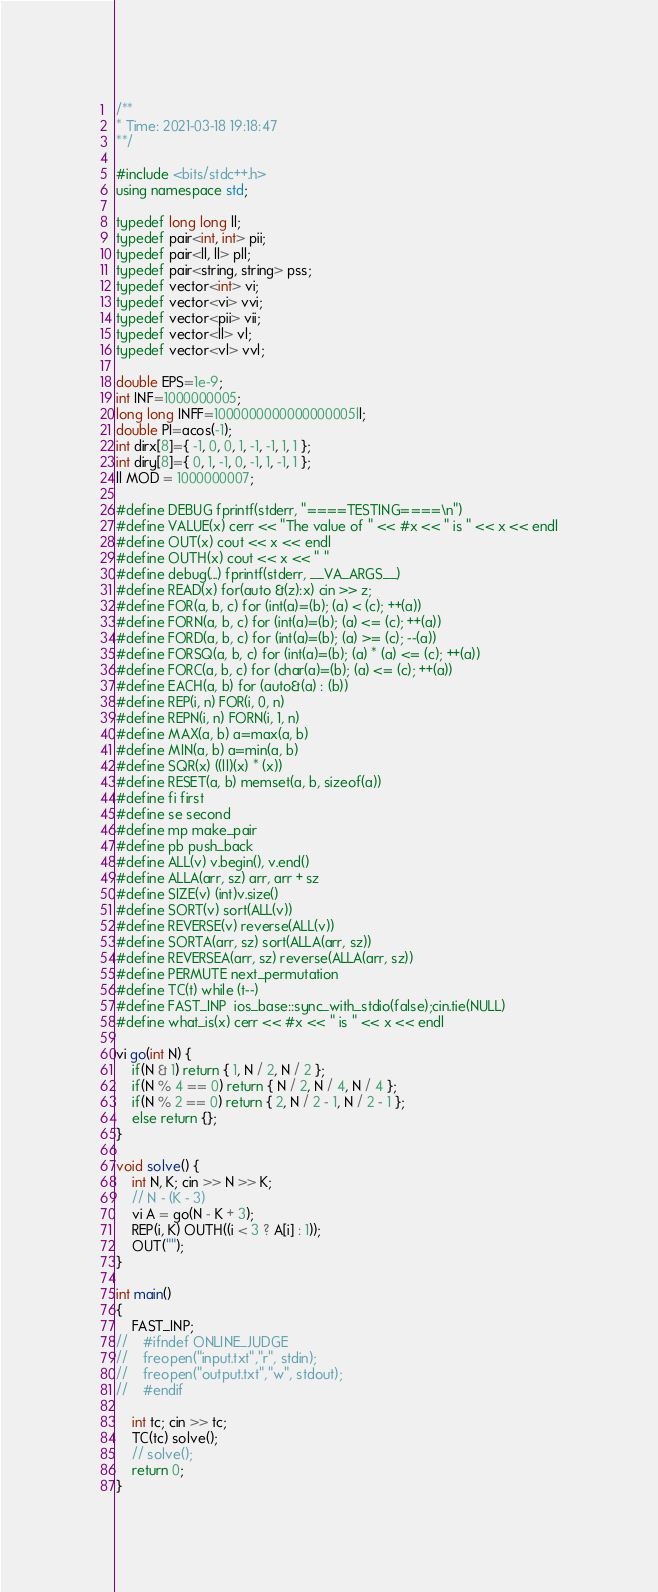Convert code to text. <code><loc_0><loc_0><loc_500><loc_500><_C++_>/** 
* Time: 2021-03-18 19:18:47
**/

#include <bits/stdc++.h>
using namespace std;

typedef long long ll;
typedef pair<int, int> pii;
typedef pair<ll, ll> pll;
typedef pair<string, string> pss;
typedef vector<int> vi;
typedef vector<vi> vvi;
typedef vector<pii> vii;
typedef vector<ll> vl;
typedef vector<vl> vvl;

double EPS=1e-9;
int INF=1000000005;
long long INFF=1000000000000000005ll;
double PI=acos(-1);
int dirx[8]={ -1, 0, 0, 1, -1, -1, 1, 1 };
int diry[8]={ 0, 1, -1, 0, -1, 1, -1, 1 };
ll MOD = 1000000007;

#define DEBUG fprintf(stderr, "====TESTING====\n")
#define VALUE(x) cerr << "The value of " << #x << " is " << x << endl
#define OUT(x) cout << x << endl
#define OUTH(x) cout << x << " "
#define debug(...) fprintf(stderr, __VA_ARGS__)
#define READ(x) for(auto &(z):x) cin >> z;
#define FOR(a, b, c) for (int(a)=(b); (a) < (c); ++(a))
#define FORN(a, b, c) for (int(a)=(b); (a) <= (c); ++(a))
#define FORD(a, b, c) for (int(a)=(b); (a) >= (c); --(a))
#define FORSQ(a, b, c) for (int(a)=(b); (a) * (a) <= (c); ++(a))
#define FORC(a, b, c) for (char(a)=(b); (a) <= (c); ++(a))
#define EACH(a, b) for (auto&(a) : (b))
#define REP(i, n) FOR(i, 0, n)
#define REPN(i, n) FORN(i, 1, n)
#define MAX(a, b) a=max(a, b)
#define MIN(a, b) a=min(a, b)
#define SQR(x) ((ll)(x) * (x))
#define RESET(a, b) memset(a, b, sizeof(a))
#define fi first
#define se second
#define mp make_pair
#define pb push_back
#define ALL(v) v.begin(), v.end()
#define ALLA(arr, sz) arr, arr + sz
#define SIZE(v) (int)v.size()
#define SORT(v) sort(ALL(v))
#define REVERSE(v) reverse(ALL(v))
#define SORTA(arr, sz) sort(ALLA(arr, sz))
#define REVERSEA(arr, sz) reverse(ALLA(arr, sz))
#define PERMUTE next_permutation
#define TC(t) while (t--)
#define FAST_INP  ios_base::sync_with_stdio(false);cin.tie(NULL)
#define what_is(x) cerr << #x << " is " << x << endl

vi go(int N) {
	if(N & 1) return { 1, N / 2, N / 2 };
	if(N % 4 == 0) return { N / 2, N / 4, N / 4 };
	if(N % 2 == 0) return { 2, N / 2 - 1, N / 2 - 1 };
	else return {};
}

void solve() {
	int N, K; cin >> N >> K;
	// N - (K - 3)
	vi A = go(N - K + 3);
	REP(i, K) OUTH((i < 3 ? A[i] : 1));
	OUT("");
}
 
int main()
{
    FAST_INP;
//    #ifndef ONLINE_JUDGE
//    freopen("input.txt","r", stdin);
//    freopen("output.txt","w", stdout);
//    #endif
 
    int tc; cin >> tc;
    TC(tc) solve();
    // solve();
    return 0;
}
</code> 